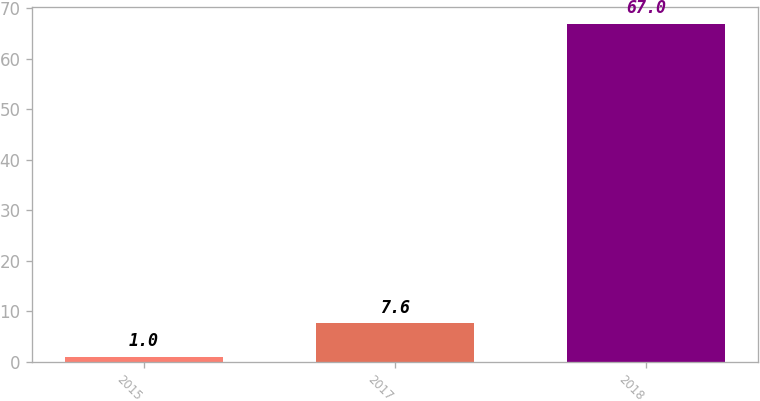Convert chart. <chart><loc_0><loc_0><loc_500><loc_500><bar_chart><fcel>2015<fcel>2017<fcel>2018<nl><fcel>1<fcel>7.6<fcel>67<nl></chart> 